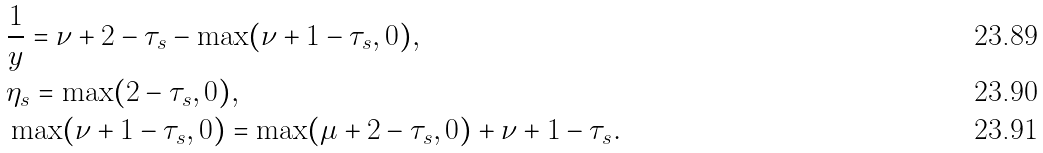<formula> <loc_0><loc_0><loc_500><loc_500>& \frac { 1 } { y } = \nu + 2 - \tau _ { s } - \max ( \nu + 1 - \tau _ { s } , 0 ) , \\ & \eta _ { s } = \max ( 2 - \tau _ { s } , 0 ) , \\ & \max ( \nu + 1 - \tau _ { s } , 0 ) = \max ( \mu + 2 - \tau _ { s } , 0 ) + \nu + 1 - \tau _ { s } .</formula> 